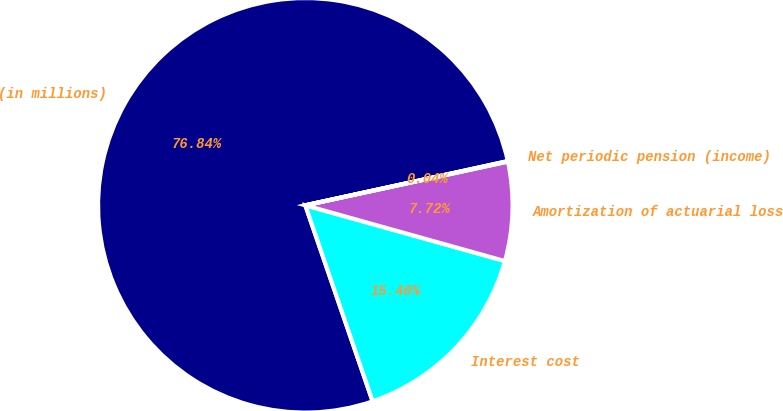Convert chart. <chart><loc_0><loc_0><loc_500><loc_500><pie_chart><fcel>(in millions)<fcel>Interest cost<fcel>Amortization of actuarial loss<fcel>Net periodic pension (income)<nl><fcel>76.84%<fcel>15.4%<fcel>7.72%<fcel>0.04%<nl></chart> 